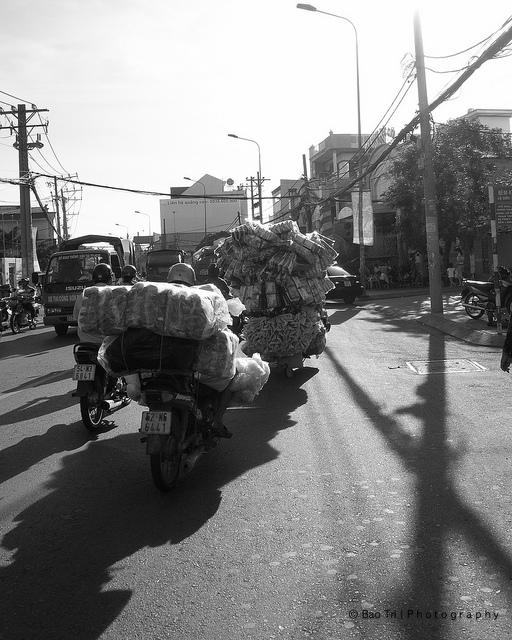What are the wires in the air?
Be succinct. Power lines. How does the traffic look?
Write a very short answer. Busy. What is on the back of the bikes?
Give a very brief answer. Packages. 